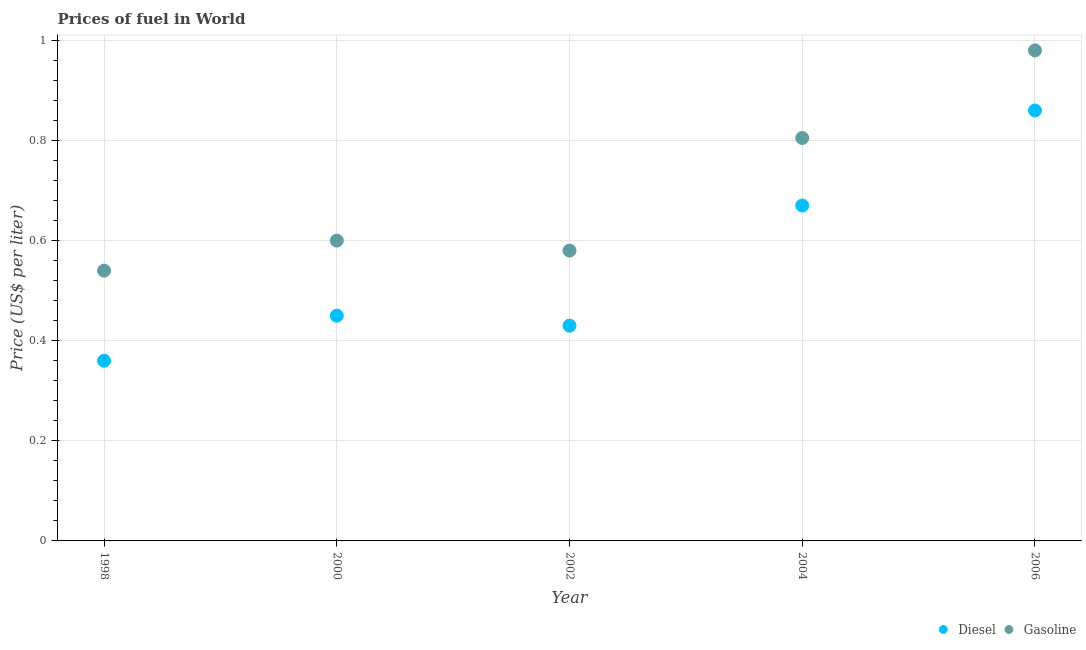What is the gasoline price in 1998?
Offer a very short reply. 0.54. Across all years, what is the maximum diesel price?
Give a very brief answer. 0.86. Across all years, what is the minimum gasoline price?
Provide a short and direct response. 0.54. In which year was the diesel price maximum?
Provide a short and direct response. 2006. In which year was the gasoline price minimum?
Your response must be concise. 1998. What is the total gasoline price in the graph?
Your answer should be very brief. 3.51. What is the difference between the diesel price in 2004 and that in 2006?
Offer a very short reply. -0.19. What is the difference between the diesel price in 2006 and the gasoline price in 2000?
Give a very brief answer. 0.26. What is the average gasoline price per year?
Provide a succinct answer. 0.7. In the year 2002, what is the difference between the diesel price and gasoline price?
Offer a terse response. -0.15. In how many years, is the diesel price greater than 0.52 US$ per litre?
Provide a short and direct response. 2. What is the ratio of the diesel price in 2002 to that in 2004?
Provide a short and direct response. 0.64. What is the difference between the highest and the second highest gasoline price?
Offer a very short reply. 0.17. Is the sum of the diesel price in 2004 and 2006 greater than the maximum gasoline price across all years?
Offer a very short reply. Yes. Does the diesel price monotonically increase over the years?
Offer a terse response. No. Is the gasoline price strictly greater than the diesel price over the years?
Offer a very short reply. Yes. How many dotlines are there?
Ensure brevity in your answer.  2. Are the values on the major ticks of Y-axis written in scientific E-notation?
Give a very brief answer. No. Does the graph contain any zero values?
Give a very brief answer. No. How many legend labels are there?
Give a very brief answer. 2. What is the title of the graph?
Provide a succinct answer. Prices of fuel in World. What is the label or title of the X-axis?
Keep it short and to the point. Year. What is the label or title of the Y-axis?
Your answer should be compact. Price (US$ per liter). What is the Price (US$ per liter) of Diesel in 1998?
Ensure brevity in your answer.  0.36. What is the Price (US$ per liter) in Gasoline in 1998?
Provide a succinct answer. 0.54. What is the Price (US$ per liter) of Diesel in 2000?
Offer a terse response. 0.45. What is the Price (US$ per liter) in Diesel in 2002?
Provide a succinct answer. 0.43. What is the Price (US$ per liter) of Gasoline in 2002?
Offer a very short reply. 0.58. What is the Price (US$ per liter) in Diesel in 2004?
Your answer should be compact. 0.67. What is the Price (US$ per liter) of Gasoline in 2004?
Keep it short and to the point. 0.81. What is the Price (US$ per liter) of Diesel in 2006?
Your answer should be very brief. 0.86. What is the Price (US$ per liter) of Gasoline in 2006?
Provide a succinct answer. 0.98. Across all years, what is the maximum Price (US$ per liter) in Diesel?
Your answer should be compact. 0.86. Across all years, what is the maximum Price (US$ per liter) in Gasoline?
Give a very brief answer. 0.98. Across all years, what is the minimum Price (US$ per liter) in Diesel?
Your answer should be very brief. 0.36. Across all years, what is the minimum Price (US$ per liter) in Gasoline?
Keep it short and to the point. 0.54. What is the total Price (US$ per liter) in Diesel in the graph?
Provide a short and direct response. 2.77. What is the total Price (US$ per liter) of Gasoline in the graph?
Provide a short and direct response. 3.5. What is the difference between the Price (US$ per liter) of Diesel in 1998 and that in 2000?
Provide a short and direct response. -0.09. What is the difference between the Price (US$ per liter) of Gasoline in 1998 and that in 2000?
Offer a terse response. -0.06. What is the difference between the Price (US$ per liter) of Diesel in 1998 and that in 2002?
Make the answer very short. -0.07. What is the difference between the Price (US$ per liter) of Gasoline in 1998 and that in 2002?
Your answer should be compact. -0.04. What is the difference between the Price (US$ per liter) of Diesel in 1998 and that in 2004?
Give a very brief answer. -0.31. What is the difference between the Price (US$ per liter) in Gasoline in 1998 and that in 2004?
Keep it short and to the point. -0.27. What is the difference between the Price (US$ per liter) of Gasoline in 1998 and that in 2006?
Give a very brief answer. -0.44. What is the difference between the Price (US$ per liter) of Diesel in 2000 and that in 2002?
Keep it short and to the point. 0.02. What is the difference between the Price (US$ per liter) of Diesel in 2000 and that in 2004?
Make the answer very short. -0.22. What is the difference between the Price (US$ per liter) of Gasoline in 2000 and that in 2004?
Ensure brevity in your answer.  -0.2. What is the difference between the Price (US$ per liter) of Diesel in 2000 and that in 2006?
Offer a terse response. -0.41. What is the difference between the Price (US$ per liter) of Gasoline in 2000 and that in 2006?
Your answer should be compact. -0.38. What is the difference between the Price (US$ per liter) in Diesel in 2002 and that in 2004?
Your response must be concise. -0.24. What is the difference between the Price (US$ per liter) of Gasoline in 2002 and that in 2004?
Provide a short and direct response. -0.23. What is the difference between the Price (US$ per liter) in Diesel in 2002 and that in 2006?
Offer a very short reply. -0.43. What is the difference between the Price (US$ per liter) of Diesel in 2004 and that in 2006?
Your answer should be very brief. -0.19. What is the difference between the Price (US$ per liter) of Gasoline in 2004 and that in 2006?
Offer a terse response. -0.17. What is the difference between the Price (US$ per liter) in Diesel in 1998 and the Price (US$ per liter) in Gasoline in 2000?
Make the answer very short. -0.24. What is the difference between the Price (US$ per liter) in Diesel in 1998 and the Price (US$ per liter) in Gasoline in 2002?
Offer a terse response. -0.22. What is the difference between the Price (US$ per liter) in Diesel in 1998 and the Price (US$ per liter) in Gasoline in 2004?
Your answer should be compact. -0.45. What is the difference between the Price (US$ per liter) in Diesel in 1998 and the Price (US$ per liter) in Gasoline in 2006?
Provide a succinct answer. -0.62. What is the difference between the Price (US$ per liter) in Diesel in 2000 and the Price (US$ per liter) in Gasoline in 2002?
Provide a succinct answer. -0.13. What is the difference between the Price (US$ per liter) in Diesel in 2000 and the Price (US$ per liter) in Gasoline in 2004?
Make the answer very short. -0.35. What is the difference between the Price (US$ per liter) of Diesel in 2000 and the Price (US$ per liter) of Gasoline in 2006?
Make the answer very short. -0.53. What is the difference between the Price (US$ per liter) of Diesel in 2002 and the Price (US$ per liter) of Gasoline in 2004?
Provide a short and direct response. -0.38. What is the difference between the Price (US$ per liter) in Diesel in 2002 and the Price (US$ per liter) in Gasoline in 2006?
Ensure brevity in your answer.  -0.55. What is the difference between the Price (US$ per liter) in Diesel in 2004 and the Price (US$ per liter) in Gasoline in 2006?
Your answer should be compact. -0.31. What is the average Price (US$ per liter) of Diesel per year?
Make the answer very short. 0.55. What is the average Price (US$ per liter) of Gasoline per year?
Ensure brevity in your answer.  0.7. In the year 1998, what is the difference between the Price (US$ per liter) of Diesel and Price (US$ per liter) of Gasoline?
Provide a succinct answer. -0.18. In the year 2002, what is the difference between the Price (US$ per liter) in Diesel and Price (US$ per liter) in Gasoline?
Ensure brevity in your answer.  -0.15. In the year 2004, what is the difference between the Price (US$ per liter) of Diesel and Price (US$ per liter) of Gasoline?
Your response must be concise. -0.14. In the year 2006, what is the difference between the Price (US$ per liter) of Diesel and Price (US$ per liter) of Gasoline?
Give a very brief answer. -0.12. What is the ratio of the Price (US$ per liter) in Diesel in 1998 to that in 2002?
Give a very brief answer. 0.84. What is the ratio of the Price (US$ per liter) in Diesel in 1998 to that in 2004?
Provide a succinct answer. 0.54. What is the ratio of the Price (US$ per liter) in Gasoline in 1998 to that in 2004?
Offer a terse response. 0.67. What is the ratio of the Price (US$ per liter) of Diesel in 1998 to that in 2006?
Offer a very short reply. 0.42. What is the ratio of the Price (US$ per liter) in Gasoline in 1998 to that in 2006?
Keep it short and to the point. 0.55. What is the ratio of the Price (US$ per liter) in Diesel in 2000 to that in 2002?
Provide a succinct answer. 1.05. What is the ratio of the Price (US$ per liter) of Gasoline in 2000 to that in 2002?
Offer a very short reply. 1.03. What is the ratio of the Price (US$ per liter) of Diesel in 2000 to that in 2004?
Give a very brief answer. 0.67. What is the ratio of the Price (US$ per liter) in Gasoline in 2000 to that in 2004?
Keep it short and to the point. 0.75. What is the ratio of the Price (US$ per liter) of Diesel in 2000 to that in 2006?
Your answer should be very brief. 0.52. What is the ratio of the Price (US$ per liter) of Gasoline in 2000 to that in 2006?
Your answer should be very brief. 0.61. What is the ratio of the Price (US$ per liter) in Diesel in 2002 to that in 2004?
Your answer should be very brief. 0.64. What is the ratio of the Price (US$ per liter) of Gasoline in 2002 to that in 2004?
Give a very brief answer. 0.72. What is the ratio of the Price (US$ per liter) of Gasoline in 2002 to that in 2006?
Keep it short and to the point. 0.59. What is the ratio of the Price (US$ per liter) of Diesel in 2004 to that in 2006?
Offer a very short reply. 0.78. What is the ratio of the Price (US$ per liter) of Gasoline in 2004 to that in 2006?
Keep it short and to the point. 0.82. What is the difference between the highest and the second highest Price (US$ per liter) of Diesel?
Make the answer very short. 0.19. What is the difference between the highest and the second highest Price (US$ per liter) in Gasoline?
Make the answer very short. 0.17. What is the difference between the highest and the lowest Price (US$ per liter) of Diesel?
Offer a very short reply. 0.5. What is the difference between the highest and the lowest Price (US$ per liter) in Gasoline?
Offer a terse response. 0.44. 